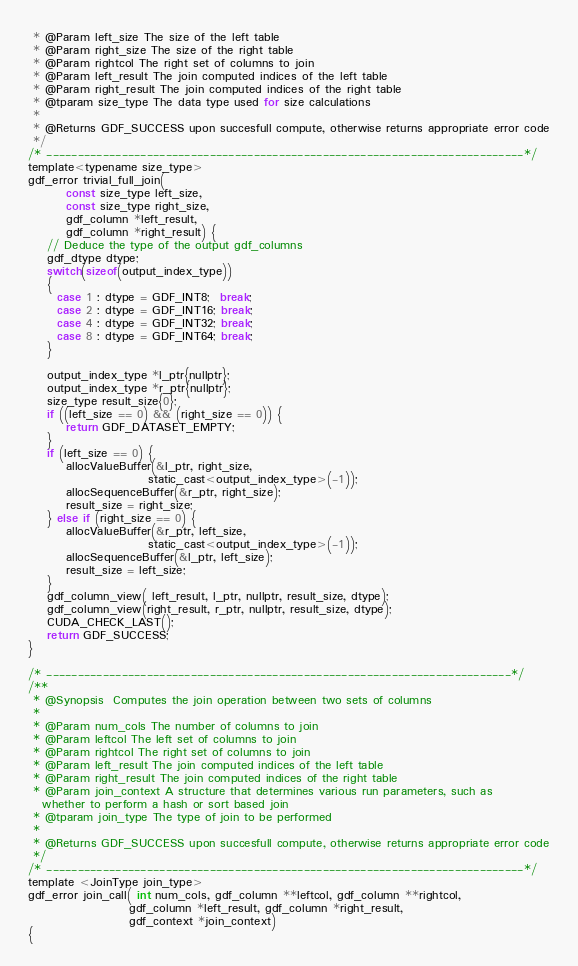<code> <loc_0><loc_0><loc_500><loc_500><_Cuda_> * @Param left_size The size of the left table
 * @Param right_size The size of the right table
 * @Param rightcol The right set of columns to join
 * @Param left_result The join computed indices of the left table
 * @Param right_result The join computed indices of the right table
 * @tparam size_type The data type used for size calculations
 * 
 * @Returns GDF_SUCCESS upon succesfull compute, otherwise returns appropriate error code
 */
/* ----------------------------------------------------------------------------*/
template<typename size_type>
gdf_error trivial_full_join(
        const size_type left_size,
        const size_type right_size,
        gdf_column *left_result,
        gdf_column *right_result) {
    // Deduce the type of the output gdf_columns
    gdf_dtype dtype;
    switch(sizeof(output_index_type))
    {
      case 1 : dtype = GDF_INT8;  break;
      case 2 : dtype = GDF_INT16; break;
      case 4 : dtype = GDF_INT32; break;
      case 8 : dtype = GDF_INT64; break;
    }

    output_index_type *l_ptr{nullptr};
    output_index_type *r_ptr{nullptr};
    size_type result_size{0};
    if ((left_size == 0) && (right_size == 0)) {
        return GDF_DATASET_EMPTY;
    }
    if (left_size == 0) {
        allocValueBuffer(&l_ptr, right_size,
                         static_cast<output_index_type>(-1));
        allocSequenceBuffer(&r_ptr, right_size);
        result_size = right_size;
    } else if (right_size == 0) {
        allocValueBuffer(&r_ptr, left_size,
                         static_cast<output_index_type>(-1));
        allocSequenceBuffer(&l_ptr, left_size);
        result_size = left_size;
    }
    gdf_column_view( left_result, l_ptr, nullptr, result_size, dtype);
    gdf_column_view(right_result, r_ptr, nullptr, result_size, dtype);
    CUDA_CHECK_LAST();
    return GDF_SUCCESS;
}

/* --------------------------------------------------------------------------*/
/** 
 * @Synopsis  Computes the join operation between two sets of columns
 * 
 * @Param num_cols The number of columns to join
 * @Param leftcol The left set of columns to join
 * @Param rightcol The right set of columns to join
 * @Param left_result The join computed indices of the left table
 * @Param right_result The join computed indices of the right table
 * @Param join_context A structure that determines various run parameters, such as
   whether to perform a hash or sort based join
 * @tparam join_type The type of join to be performed
 * 
 * @Returns GDF_SUCCESS upon succesfull compute, otherwise returns appropriate error code
 */
/* ----------------------------------------------------------------------------*/
template <JoinType join_type>
gdf_error join_call( int num_cols, gdf_column **leftcol, gdf_column **rightcol,
                     gdf_column *left_result, gdf_column *right_result,
                     gdf_context *join_context)
{
</code> 